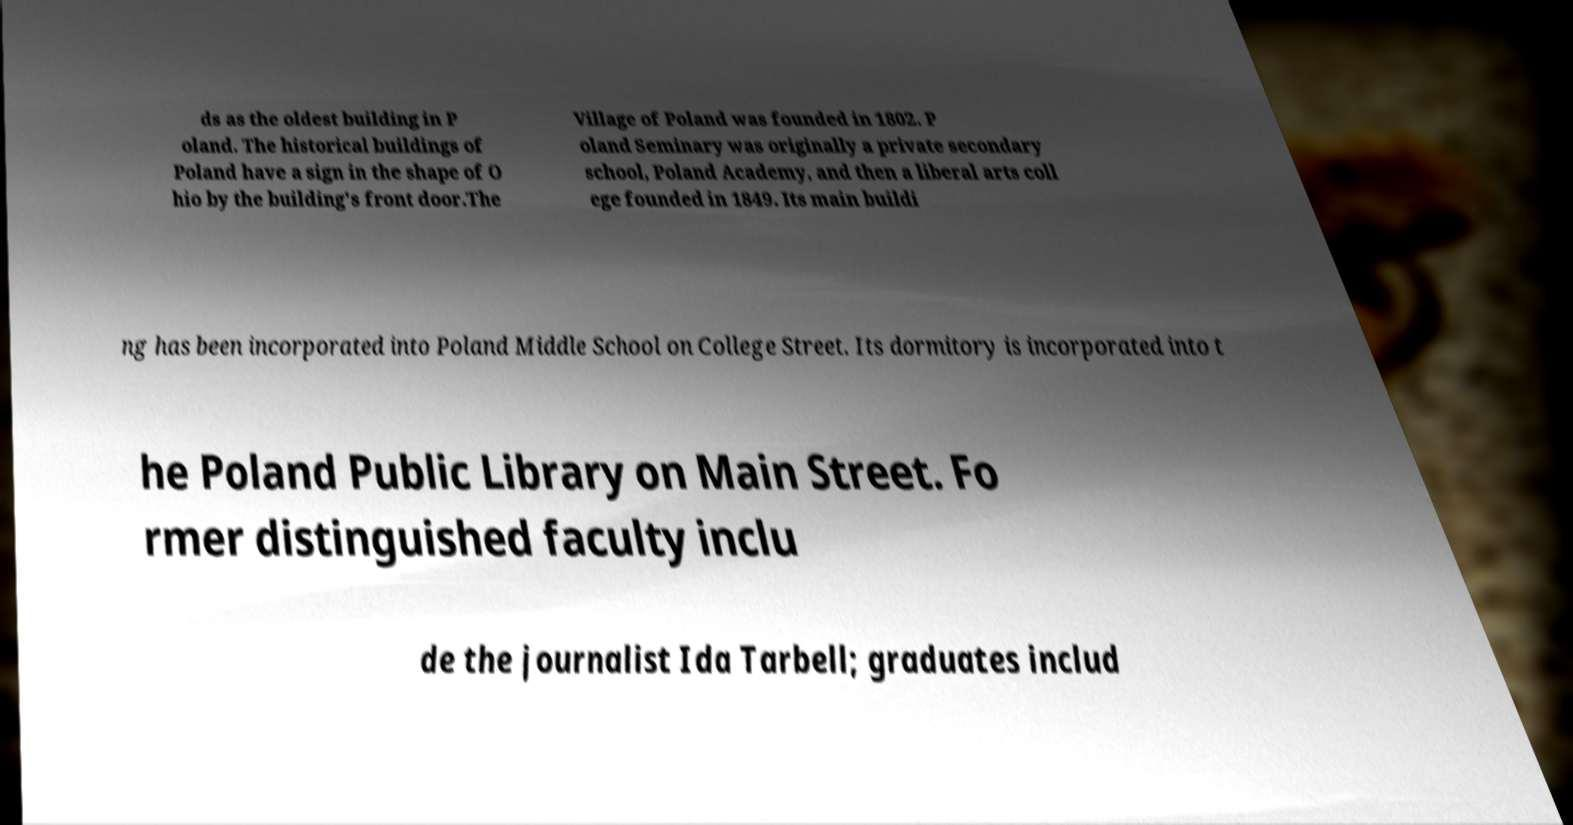For documentation purposes, I need the text within this image transcribed. Could you provide that? ds as the oldest building in P oland. The historical buildings of Poland have a sign in the shape of O hio by the building's front door.The Village of Poland was founded in 1802. P oland Seminary was originally a private secondary school, Poland Academy, and then a liberal arts coll ege founded in 1849. Its main buildi ng has been incorporated into Poland Middle School on College Street. Its dormitory is incorporated into t he Poland Public Library on Main Street. Fo rmer distinguished faculty inclu de the journalist Ida Tarbell; graduates includ 